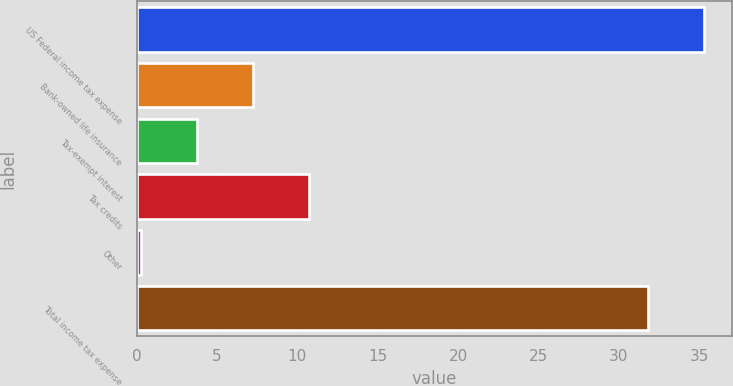Convert chart. <chart><loc_0><loc_0><loc_500><loc_500><bar_chart><fcel>US Federal income tax expense<fcel>Bank-owned life insurance<fcel>Tax-exempt interest<fcel>Tax credits<fcel>Other<fcel>Total income tax expense<nl><fcel>35.27<fcel>7.24<fcel>3.77<fcel>10.71<fcel>0.3<fcel>31.8<nl></chart> 